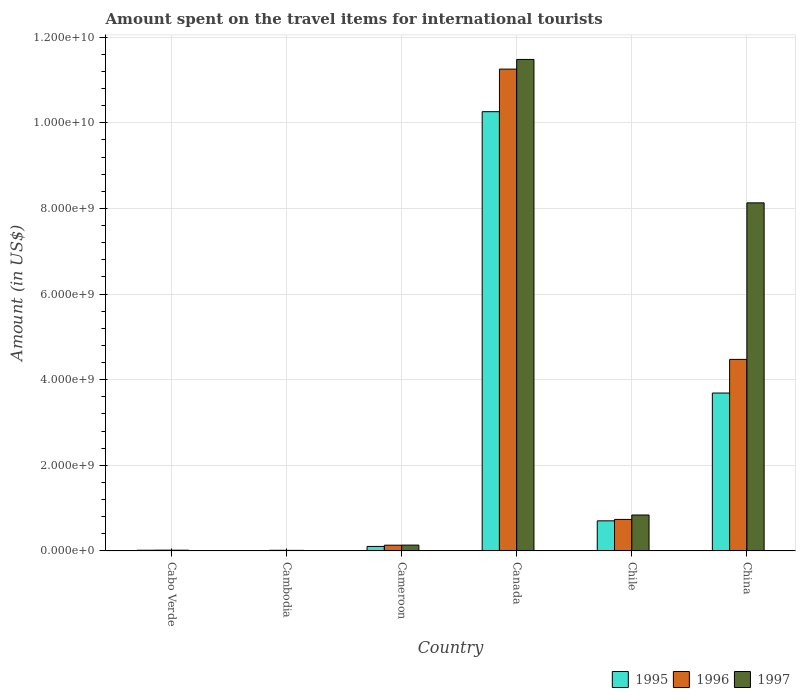How many groups of bars are there?
Provide a succinct answer. 6. Are the number of bars per tick equal to the number of legend labels?
Give a very brief answer. Yes. Are the number of bars on each tick of the X-axis equal?
Provide a succinct answer. Yes. What is the amount spent on the travel items for international tourists in 1995 in Canada?
Provide a succinct answer. 1.03e+1. Across all countries, what is the maximum amount spent on the travel items for international tourists in 1997?
Ensure brevity in your answer.  1.15e+1. Across all countries, what is the minimum amount spent on the travel items for international tourists in 1996?
Your response must be concise. 1.50e+07. In which country was the amount spent on the travel items for international tourists in 1995 minimum?
Your answer should be compact. Cambodia. What is the total amount spent on the travel items for international tourists in 1995 in the graph?
Provide a short and direct response. 1.48e+1. What is the difference between the amount spent on the travel items for international tourists in 1995 in Cambodia and that in Cameroon?
Provide a short and direct response. -9.70e+07. What is the difference between the amount spent on the travel items for international tourists in 1995 in China and the amount spent on the travel items for international tourists in 1996 in Canada?
Provide a short and direct response. -7.57e+09. What is the average amount spent on the travel items for international tourists in 1995 per country?
Make the answer very short. 2.46e+09. What is the difference between the amount spent on the travel items for international tourists of/in 1995 and amount spent on the travel items for international tourists of/in 1996 in Cambodia?
Keep it short and to the point. -7.00e+06. In how many countries, is the amount spent on the travel items for international tourists in 1995 greater than 8800000000 US$?
Your answer should be very brief. 1. What is the ratio of the amount spent on the travel items for international tourists in 1995 in Cabo Verde to that in Cambodia?
Provide a succinct answer. 2. Is the amount spent on the travel items for international tourists in 1995 in Cambodia less than that in Chile?
Keep it short and to the point. Yes. What is the difference between the highest and the second highest amount spent on the travel items for international tourists in 1995?
Offer a terse response. 6.57e+09. What is the difference between the highest and the lowest amount spent on the travel items for international tourists in 1996?
Your answer should be very brief. 1.12e+1. In how many countries, is the amount spent on the travel items for international tourists in 1995 greater than the average amount spent on the travel items for international tourists in 1995 taken over all countries?
Give a very brief answer. 2. How many countries are there in the graph?
Keep it short and to the point. 6. What is the difference between two consecutive major ticks on the Y-axis?
Ensure brevity in your answer.  2.00e+09. Are the values on the major ticks of Y-axis written in scientific E-notation?
Your answer should be very brief. Yes. How many legend labels are there?
Your answer should be compact. 3. How are the legend labels stacked?
Ensure brevity in your answer.  Horizontal. What is the title of the graph?
Your response must be concise. Amount spent on the travel items for international tourists. Does "2003" appear as one of the legend labels in the graph?
Offer a terse response. No. What is the label or title of the X-axis?
Keep it short and to the point. Country. What is the Amount (in US$) in 1995 in Cabo Verde?
Offer a very short reply. 1.60e+07. What is the Amount (in US$) in 1996 in Cabo Verde?
Your answer should be compact. 1.80e+07. What is the Amount (in US$) of 1997 in Cabo Verde?
Your answer should be compact. 1.70e+07. What is the Amount (in US$) of 1996 in Cambodia?
Your answer should be very brief. 1.50e+07. What is the Amount (in US$) of 1997 in Cambodia?
Provide a short and direct response. 1.30e+07. What is the Amount (in US$) in 1995 in Cameroon?
Your answer should be very brief. 1.05e+08. What is the Amount (in US$) of 1996 in Cameroon?
Provide a succinct answer. 1.34e+08. What is the Amount (in US$) of 1997 in Cameroon?
Your response must be concise. 1.36e+08. What is the Amount (in US$) in 1995 in Canada?
Your response must be concise. 1.03e+1. What is the Amount (in US$) in 1996 in Canada?
Provide a short and direct response. 1.13e+1. What is the Amount (in US$) in 1997 in Canada?
Your answer should be very brief. 1.15e+1. What is the Amount (in US$) in 1995 in Chile?
Offer a very short reply. 7.03e+08. What is the Amount (in US$) in 1996 in Chile?
Give a very brief answer. 7.36e+08. What is the Amount (in US$) of 1997 in Chile?
Make the answer very short. 8.39e+08. What is the Amount (in US$) of 1995 in China?
Your answer should be very brief. 3.69e+09. What is the Amount (in US$) in 1996 in China?
Offer a terse response. 4.47e+09. What is the Amount (in US$) of 1997 in China?
Your answer should be compact. 8.13e+09. Across all countries, what is the maximum Amount (in US$) of 1995?
Keep it short and to the point. 1.03e+1. Across all countries, what is the maximum Amount (in US$) in 1996?
Keep it short and to the point. 1.13e+1. Across all countries, what is the maximum Amount (in US$) in 1997?
Make the answer very short. 1.15e+1. Across all countries, what is the minimum Amount (in US$) of 1995?
Ensure brevity in your answer.  8.00e+06. Across all countries, what is the minimum Amount (in US$) of 1996?
Offer a terse response. 1.50e+07. Across all countries, what is the minimum Amount (in US$) of 1997?
Offer a terse response. 1.30e+07. What is the total Amount (in US$) of 1995 in the graph?
Make the answer very short. 1.48e+1. What is the total Amount (in US$) in 1996 in the graph?
Your answer should be very brief. 1.66e+1. What is the total Amount (in US$) of 1997 in the graph?
Your answer should be very brief. 2.06e+1. What is the difference between the Amount (in US$) of 1995 in Cabo Verde and that in Cambodia?
Your response must be concise. 8.00e+06. What is the difference between the Amount (in US$) in 1997 in Cabo Verde and that in Cambodia?
Provide a short and direct response. 4.00e+06. What is the difference between the Amount (in US$) in 1995 in Cabo Verde and that in Cameroon?
Give a very brief answer. -8.90e+07. What is the difference between the Amount (in US$) in 1996 in Cabo Verde and that in Cameroon?
Your answer should be very brief. -1.16e+08. What is the difference between the Amount (in US$) in 1997 in Cabo Verde and that in Cameroon?
Provide a short and direct response. -1.19e+08. What is the difference between the Amount (in US$) of 1995 in Cabo Verde and that in Canada?
Offer a terse response. -1.02e+1. What is the difference between the Amount (in US$) of 1996 in Cabo Verde and that in Canada?
Ensure brevity in your answer.  -1.12e+1. What is the difference between the Amount (in US$) in 1997 in Cabo Verde and that in Canada?
Provide a short and direct response. -1.15e+1. What is the difference between the Amount (in US$) in 1995 in Cabo Verde and that in Chile?
Provide a succinct answer. -6.87e+08. What is the difference between the Amount (in US$) in 1996 in Cabo Verde and that in Chile?
Make the answer very short. -7.18e+08. What is the difference between the Amount (in US$) in 1997 in Cabo Verde and that in Chile?
Your answer should be compact. -8.22e+08. What is the difference between the Amount (in US$) of 1995 in Cabo Verde and that in China?
Make the answer very short. -3.67e+09. What is the difference between the Amount (in US$) of 1996 in Cabo Verde and that in China?
Keep it short and to the point. -4.46e+09. What is the difference between the Amount (in US$) in 1997 in Cabo Verde and that in China?
Offer a very short reply. -8.11e+09. What is the difference between the Amount (in US$) in 1995 in Cambodia and that in Cameroon?
Your answer should be very brief. -9.70e+07. What is the difference between the Amount (in US$) in 1996 in Cambodia and that in Cameroon?
Keep it short and to the point. -1.19e+08. What is the difference between the Amount (in US$) in 1997 in Cambodia and that in Cameroon?
Offer a very short reply. -1.23e+08. What is the difference between the Amount (in US$) in 1995 in Cambodia and that in Canada?
Provide a short and direct response. -1.03e+1. What is the difference between the Amount (in US$) of 1996 in Cambodia and that in Canada?
Ensure brevity in your answer.  -1.12e+1. What is the difference between the Amount (in US$) of 1997 in Cambodia and that in Canada?
Give a very brief answer. -1.15e+1. What is the difference between the Amount (in US$) of 1995 in Cambodia and that in Chile?
Give a very brief answer. -6.95e+08. What is the difference between the Amount (in US$) in 1996 in Cambodia and that in Chile?
Keep it short and to the point. -7.21e+08. What is the difference between the Amount (in US$) of 1997 in Cambodia and that in Chile?
Offer a very short reply. -8.26e+08. What is the difference between the Amount (in US$) in 1995 in Cambodia and that in China?
Offer a very short reply. -3.68e+09. What is the difference between the Amount (in US$) in 1996 in Cambodia and that in China?
Ensure brevity in your answer.  -4.46e+09. What is the difference between the Amount (in US$) of 1997 in Cambodia and that in China?
Your response must be concise. -8.12e+09. What is the difference between the Amount (in US$) in 1995 in Cameroon and that in Canada?
Offer a very short reply. -1.02e+1. What is the difference between the Amount (in US$) of 1996 in Cameroon and that in Canada?
Make the answer very short. -1.11e+1. What is the difference between the Amount (in US$) in 1997 in Cameroon and that in Canada?
Your answer should be compact. -1.13e+1. What is the difference between the Amount (in US$) in 1995 in Cameroon and that in Chile?
Offer a very short reply. -5.98e+08. What is the difference between the Amount (in US$) of 1996 in Cameroon and that in Chile?
Keep it short and to the point. -6.02e+08. What is the difference between the Amount (in US$) in 1997 in Cameroon and that in Chile?
Provide a short and direct response. -7.03e+08. What is the difference between the Amount (in US$) in 1995 in Cameroon and that in China?
Your answer should be very brief. -3.58e+09. What is the difference between the Amount (in US$) of 1996 in Cameroon and that in China?
Give a very brief answer. -4.34e+09. What is the difference between the Amount (in US$) of 1997 in Cameroon and that in China?
Offer a terse response. -7.99e+09. What is the difference between the Amount (in US$) in 1995 in Canada and that in Chile?
Ensure brevity in your answer.  9.56e+09. What is the difference between the Amount (in US$) of 1996 in Canada and that in Chile?
Make the answer very short. 1.05e+1. What is the difference between the Amount (in US$) in 1997 in Canada and that in Chile?
Your response must be concise. 1.06e+1. What is the difference between the Amount (in US$) in 1995 in Canada and that in China?
Your response must be concise. 6.57e+09. What is the difference between the Amount (in US$) of 1996 in Canada and that in China?
Your answer should be compact. 6.78e+09. What is the difference between the Amount (in US$) of 1997 in Canada and that in China?
Provide a succinct answer. 3.35e+09. What is the difference between the Amount (in US$) of 1995 in Chile and that in China?
Keep it short and to the point. -2.98e+09. What is the difference between the Amount (in US$) of 1996 in Chile and that in China?
Offer a very short reply. -3.74e+09. What is the difference between the Amount (in US$) in 1997 in Chile and that in China?
Provide a short and direct response. -7.29e+09. What is the difference between the Amount (in US$) of 1995 in Cabo Verde and the Amount (in US$) of 1997 in Cambodia?
Offer a terse response. 3.00e+06. What is the difference between the Amount (in US$) of 1995 in Cabo Verde and the Amount (in US$) of 1996 in Cameroon?
Offer a very short reply. -1.18e+08. What is the difference between the Amount (in US$) in 1995 in Cabo Verde and the Amount (in US$) in 1997 in Cameroon?
Your response must be concise. -1.20e+08. What is the difference between the Amount (in US$) in 1996 in Cabo Verde and the Amount (in US$) in 1997 in Cameroon?
Offer a terse response. -1.18e+08. What is the difference between the Amount (in US$) of 1995 in Cabo Verde and the Amount (in US$) of 1996 in Canada?
Your answer should be compact. -1.12e+1. What is the difference between the Amount (in US$) of 1995 in Cabo Verde and the Amount (in US$) of 1997 in Canada?
Your response must be concise. -1.15e+1. What is the difference between the Amount (in US$) in 1996 in Cabo Verde and the Amount (in US$) in 1997 in Canada?
Offer a terse response. -1.15e+1. What is the difference between the Amount (in US$) of 1995 in Cabo Verde and the Amount (in US$) of 1996 in Chile?
Keep it short and to the point. -7.20e+08. What is the difference between the Amount (in US$) in 1995 in Cabo Verde and the Amount (in US$) in 1997 in Chile?
Ensure brevity in your answer.  -8.23e+08. What is the difference between the Amount (in US$) of 1996 in Cabo Verde and the Amount (in US$) of 1997 in Chile?
Offer a very short reply. -8.21e+08. What is the difference between the Amount (in US$) of 1995 in Cabo Verde and the Amount (in US$) of 1996 in China?
Keep it short and to the point. -4.46e+09. What is the difference between the Amount (in US$) in 1995 in Cabo Verde and the Amount (in US$) in 1997 in China?
Your answer should be compact. -8.11e+09. What is the difference between the Amount (in US$) of 1996 in Cabo Verde and the Amount (in US$) of 1997 in China?
Your response must be concise. -8.11e+09. What is the difference between the Amount (in US$) in 1995 in Cambodia and the Amount (in US$) in 1996 in Cameroon?
Offer a terse response. -1.26e+08. What is the difference between the Amount (in US$) of 1995 in Cambodia and the Amount (in US$) of 1997 in Cameroon?
Provide a succinct answer. -1.28e+08. What is the difference between the Amount (in US$) in 1996 in Cambodia and the Amount (in US$) in 1997 in Cameroon?
Provide a short and direct response. -1.21e+08. What is the difference between the Amount (in US$) of 1995 in Cambodia and the Amount (in US$) of 1996 in Canada?
Your answer should be very brief. -1.12e+1. What is the difference between the Amount (in US$) of 1995 in Cambodia and the Amount (in US$) of 1997 in Canada?
Ensure brevity in your answer.  -1.15e+1. What is the difference between the Amount (in US$) in 1996 in Cambodia and the Amount (in US$) in 1997 in Canada?
Your answer should be very brief. -1.15e+1. What is the difference between the Amount (in US$) of 1995 in Cambodia and the Amount (in US$) of 1996 in Chile?
Ensure brevity in your answer.  -7.28e+08. What is the difference between the Amount (in US$) of 1995 in Cambodia and the Amount (in US$) of 1997 in Chile?
Give a very brief answer. -8.31e+08. What is the difference between the Amount (in US$) in 1996 in Cambodia and the Amount (in US$) in 1997 in Chile?
Make the answer very short. -8.24e+08. What is the difference between the Amount (in US$) in 1995 in Cambodia and the Amount (in US$) in 1996 in China?
Make the answer very short. -4.47e+09. What is the difference between the Amount (in US$) of 1995 in Cambodia and the Amount (in US$) of 1997 in China?
Your response must be concise. -8.12e+09. What is the difference between the Amount (in US$) in 1996 in Cambodia and the Amount (in US$) in 1997 in China?
Keep it short and to the point. -8.12e+09. What is the difference between the Amount (in US$) of 1995 in Cameroon and the Amount (in US$) of 1996 in Canada?
Give a very brief answer. -1.11e+1. What is the difference between the Amount (in US$) in 1995 in Cameroon and the Amount (in US$) in 1997 in Canada?
Your answer should be compact. -1.14e+1. What is the difference between the Amount (in US$) in 1996 in Cameroon and the Amount (in US$) in 1997 in Canada?
Make the answer very short. -1.13e+1. What is the difference between the Amount (in US$) of 1995 in Cameroon and the Amount (in US$) of 1996 in Chile?
Give a very brief answer. -6.31e+08. What is the difference between the Amount (in US$) in 1995 in Cameroon and the Amount (in US$) in 1997 in Chile?
Offer a very short reply. -7.34e+08. What is the difference between the Amount (in US$) in 1996 in Cameroon and the Amount (in US$) in 1997 in Chile?
Offer a terse response. -7.05e+08. What is the difference between the Amount (in US$) in 1995 in Cameroon and the Amount (in US$) in 1996 in China?
Your answer should be very brief. -4.37e+09. What is the difference between the Amount (in US$) in 1995 in Cameroon and the Amount (in US$) in 1997 in China?
Your answer should be very brief. -8.02e+09. What is the difference between the Amount (in US$) of 1996 in Cameroon and the Amount (in US$) of 1997 in China?
Your response must be concise. -8.00e+09. What is the difference between the Amount (in US$) in 1995 in Canada and the Amount (in US$) in 1996 in Chile?
Your response must be concise. 9.52e+09. What is the difference between the Amount (in US$) in 1995 in Canada and the Amount (in US$) in 1997 in Chile?
Your answer should be compact. 9.42e+09. What is the difference between the Amount (in US$) in 1996 in Canada and the Amount (in US$) in 1997 in Chile?
Ensure brevity in your answer.  1.04e+1. What is the difference between the Amount (in US$) of 1995 in Canada and the Amount (in US$) of 1996 in China?
Give a very brief answer. 5.79e+09. What is the difference between the Amount (in US$) of 1995 in Canada and the Amount (in US$) of 1997 in China?
Keep it short and to the point. 2.13e+09. What is the difference between the Amount (in US$) of 1996 in Canada and the Amount (in US$) of 1997 in China?
Offer a terse response. 3.12e+09. What is the difference between the Amount (in US$) in 1995 in Chile and the Amount (in US$) in 1996 in China?
Offer a very short reply. -3.77e+09. What is the difference between the Amount (in US$) of 1995 in Chile and the Amount (in US$) of 1997 in China?
Give a very brief answer. -7.43e+09. What is the difference between the Amount (in US$) in 1996 in Chile and the Amount (in US$) in 1997 in China?
Offer a very short reply. -7.39e+09. What is the average Amount (in US$) in 1995 per country?
Offer a terse response. 2.46e+09. What is the average Amount (in US$) in 1996 per country?
Your answer should be very brief. 2.77e+09. What is the average Amount (in US$) in 1997 per country?
Keep it short and to the point. 3.44e+09. What is the difference between the Amount (in US$) in 1995 and Amount (in US$) in 1996 in Cambodia?
Your answer should be very brief. -7.00e+06. What is the difference between the Amount (in US$) in 1995 and Amount (in US$) in 1997 in Cambodia?
Offer a terse response. -5.00e+06. What is the difference between the Amount (in US$) of 1996 and Amount (in US$) of 1997 in Cambodia?
Offer a terse response. 2.00e+06. What is the difference between the Amount (in US$) of 1995 and Amount (in US$) of 1996 in Cameroon?
Give a very brief answer. -2.90e+07. What is the difference between the Amount (in US$) of 1995 and Amount (in US$) of 1997 in Cameroon?
Give a very brief answer. -3.10e+07. What is the difference between the Amount (in US$) of 1995 and Amount (in US$) of 1996 in Canada?
Give a very brief answer. -9.94e+08. What is the difference between the Amount (in US$) in 1995 and Amount (in US$) in 1997 in Canada?
Offer a very short reply. -1.22e+09. What is the difference between the Amount (in US$) in 1996 and Amount (in US$) in 1997 in Canada?
Make the answer very short. -2.26e+08. What is the difference between the Amount (in US$) in 1995 and Amount (in US$) in 1996 in Chile?
Your response must be concise. -3.30e+07. What is the difference between the Amount (in US$) in 1995 and Amount (in US$) in 1997 in Chile?
Keep it short and to the point. -1.36e+08. What is the difference between the Amount (in US$) in 1996 and Amount (in US$) in 1997 in Chile?
Ensure brevity in your answer.  -1.03e+08. What is the difference between the Amount (in US$) of 1995 and Amount (in US$) of 1996 in China?
Give a very brief answer. -7.86e+08. What is the difference between the Amount (in US$) of 1995 and Amount (in US$) of 1997 in China?
Offer a very short reply. -4.44e+09. What is the difference between the Amount (in US$) in 1996 and Amount (in US$) in 1997 in China?
Offer a very short reply. -3.66e+09. What is the ratio of the Amount (in US$) of 1997 in Cabo Verde to that in Cambodia?
Give a very brief answer. 1.31. What is the ratio of the Amount (in US$) in 1995 in Cabo Verde to that in Cameroon?
Provide a short and direct response. 0.15. What is the ratio of the Amount (in US$) of 1996 in Cabo Verde to that in Cameroon?
Your answer should be very brief. 0.13. What is the ratio of the Amount (in US$) of 1995 in Cabo Verde to that in Canada?
Your answer should be compact. 0. What is the ratio of the Amount (in US$) of 1996 in Cabo Verde to that in Canada?
Make the answer very short. 0. What is the ratio of the Amount (in US$) of 1997 in Cabo Verde to that in Canada?
Your response must be concise. 0. What is the ratio of the Amount (in US$) in 1995 in Cabo Verde to that in Chile?
Give a very brief answer. 0.02. What is the ratio of the Amount (in US$) in 1996 in Cabo Verde to that in Chile?
Offer a very short reply. 0.02. What is the ratio of the Amount (in US$) of 1997 in Cabo Verde to that in Chile?
Your response must be concise. 0.02. What is the ratio of the Amount (in US$) in 1995 in Cabo Verde to that in China?
Ensure brevity in your answer.  0. What is the ratio of the Amount (in US$) of 1996 in Cabo Verde to that in China?
Give a very brief answer. 0. What is the ratio of the Amount (in US$) of 1997 in Cabo Verde to that in China?
Your answer should be very brief. 0. What is the ratio of the Amount (in US$) in 1995 in Cambodia to that in Cameroon?
Keep it short and to the point. 0.08. What is the ratio of the Amount (in US$) in 1996 in Cambodia to that in Cameroon?
Ensure brevity in your answer.  0.11. What is the ratio of the Amount (in US$) of 1997 in Cambodia to that in Cameroon?
Keep it short and to the point. 0.1. What is the ratio of the Amount (in US$) in 1995 in Cambodia to that in Canada?
Offer a very short reply. 0. What is the ratio of the Amount (in US$) of 1996 in Cambodia to that in Canada?
Give a very brief answer. 0. What is the ratio of the Amount (in US$) in 1997 in Cambodia to that in Canada?
Keep it short and to the point. 0. What is the ratio of the Amount (in US$) of 1995 in Cambodia to that in Chile?
Your answer should be compact. 0.01. What is the ratio of the Amount (in US$) in 1996 in Cambodia to that in Chile?
Your response must be concise. 0.02. What is the ratio of the Amount (in US$) of 1997 in Cambodia to that in Chile?
Your answer should be very brief. 0.02. What is the ratio of the Amount (in US$) of 1995 in Cambodia to that in China?
Give a very brief answer. 0. What is the ratio of the Amount (in US$) of 1996 in Cambodia to that in China?
Your answer should be compact. 0. What is the ratio of the Amount (in US$) in 1997 in Cambodia to that in China?
Your answer should be very brief. 0. What is the ratio of the Amount (in US$) of 1995 in Cameroon to that in Canada?
Offer a terse response. 0.01. What is the ratio of the Amount (in US$) of 1996 in Cameroon to that in Canada?
Your answer should be compact. 0.01. What is the ratio of the Amount (in US$) in 1997 in Cameroon to that in Canada?
Make the answer very short. 0.01. What is the ratio of the Amount (in US$) of 1995 in Cameroon to that in Chile?
Give a very brief answer. 0.15. What is the ratio of the Amount (in US$) in 1996 in Cameroon to that in Chile?
Your answer should be compact. 0.18. What is the ratio of the Amount (in US$) of 1997 in Cameroon to that in Chile?
Ensure brevity in your answer.  0.16. What is the ratio of the Amount (in US$) in 1995 in Cameroon to that in China?
Your answer should be very brief. 0.03. What is the ratio of the Amount (in US$) in 1996 in Cameroon to that in China?
Provide a succinct answer. 0.03. What is the ratio of the Amount (in US$) in 1997 in Cameroon to that in China?
Offer a terse response. 0.02. What is the ratio of the Amount (in US$) of 1995 in Canada to that in Chile?
Your response must be concise. 14.59. What is the ratio of the Amount (in US$) of 1996 in Canada to that in Chile?
Provide a short and direct response. 15.29. What is the ratio of the Amount (in US$) in 1997 in Canada to that in Chile?
Give a very brief answer. 13.68. What is the ratio of the Amount (in US$) of 1995 in Canada to that in China?
Give a very brief answer. 2.78. What is the ratio of the Amount (in US$) of 1996 in Canada to that in China?
Your answer should be compact. 2.52. What is the ratio of the Amount (in US$) in 1997 in Canada to that in China?
Give a very brief answer. 1.41. What is the ratio of the Amount (in US$) in 1995 in Chile to that in China?
Make the answer very short. 0.19. What is the ratio of the Amount (in US$) in 1996 in Chile to that in China?
Provide a succinct answer. 0.16. What is the ratio of the Amount (in US$) in 1997 in Chile to that in China?
Your answer should be compact. 0.1. What is the difference between the highest and the second highest Amount (in US$) of 1995?
Keep it short and to the point. 6.57e+09. What is the difference between the highest and the second highest Amount (in US$) in 1996?
Offer a terse response. 6.78e+09. What is the difference between the highest and the second highest Amount (in US$) in 1997?
Make the answer very short. 3.35e+09. What is the difference between the highest and the lowest Amount (in US$) in 1995?
Your answer should be very brief. 1.03e+1. What is the difference between the highest and the lowest Amount (in US$) of 1996?
Provide a short and direct response. 1.12e+1. What is the difference between the highest and the lowest Amount (in US$) of 1997?
Offer a very short reply. 1.15e+1. 